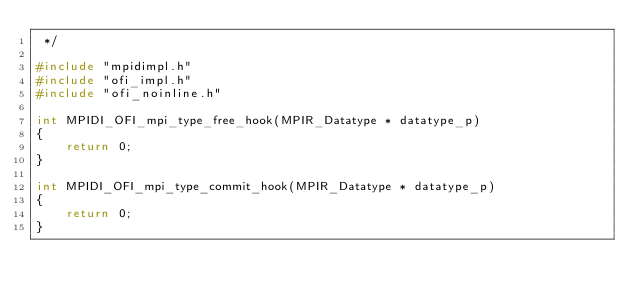Convert code to text. <code><loc_0><loc_0><loc_500><loc_500><_C_> */

#include "mpidimpl.h"
#include "ofi_impl.h"
#include "ofi_noinline.h"

int MPIDI_OFI_mpi_type_free_hook(MPIR_Datatype * datatype_p)
{
    return 0;
}

int MPIDI_OFI_mpi_type_commit_hook(MPIR_Datatype * datatype_p)
{
    return 0;
}
</code> 